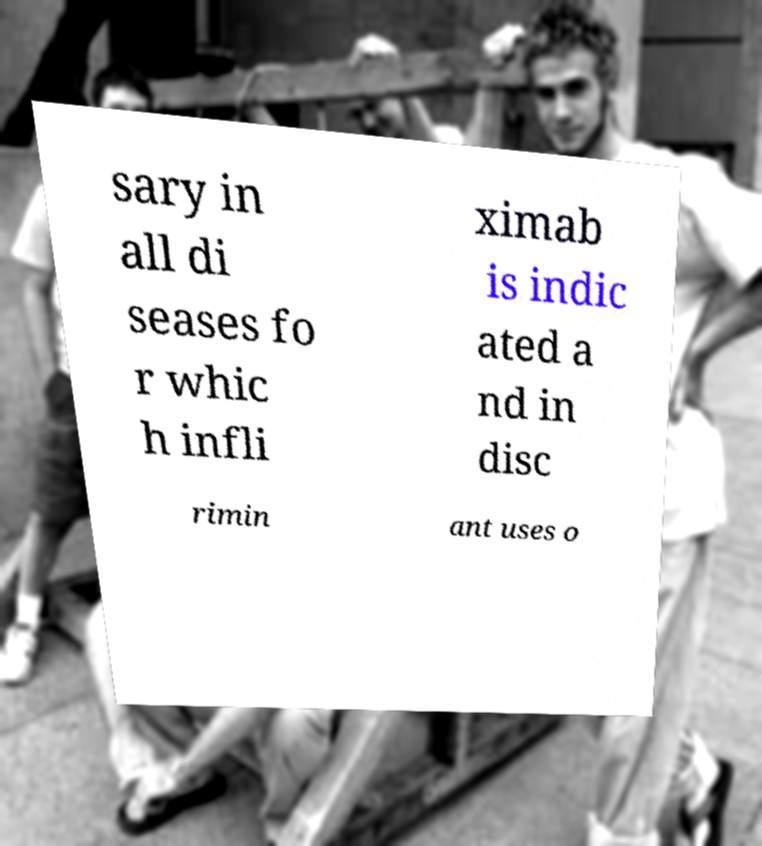Can you accurately transcribe the text from the provided image for me? sary in all di seases fo r whic h infli ximab is indic ated a nd in disc rimin ant uses o 